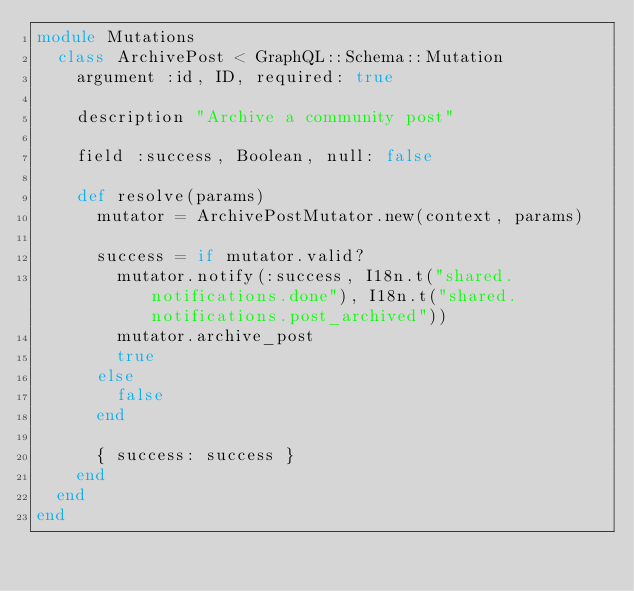Convert code to text. <code><loc_0><loc_0><loc_500><loc_500><_Ruby_>module Mutations
  class ArchivePost < GraphQL::Schema::Mutation
    argument :id, ID, required: true

    description "Archive a community post"

    field :success, Boolean, null: false

    def resolve(params)
      mutator = ArchivePostMutator.new(context, params)

      success = if mutator.valid?
        mutator.notify(:success, I18n.t("shared.notifications.done"), I18n.t("shared.notifications.post_archived"))
        mutator.archive_post
        true
      else
        false
      end

      { success: success }
    end
  end
end
</code> 